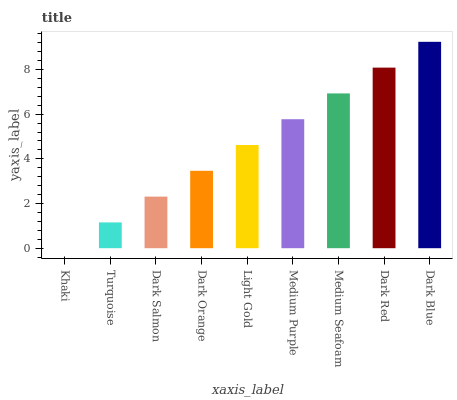Is Khaki the minimum?
Answer yes or no. Yes. Is Dark Blue the maximum?
Answer yes or no. Yes. Is Turquoise the minimum?
Answer yes or no. No. Is Turquoise the maximum?
Answer yes or no. No. Is Turquoise greater than Khaki?
Answer yes or no. Yes. Is Khaki less than Turquoise?
Answer yes or no. Yes. Is Khaki greater than Turquoise?
Answer yes or no. No. Is Turquoise less than Khaki?
Answer yes or no. No. Is Light Gold the high median?
Answer yes or no. Yes. Is Light Gold the low median?
Answer yes or no. Yes. Is Dark Salmon the high median?
Answer yes or no. No. Is Medium Purple the low median?
Answer yes or no. No. 